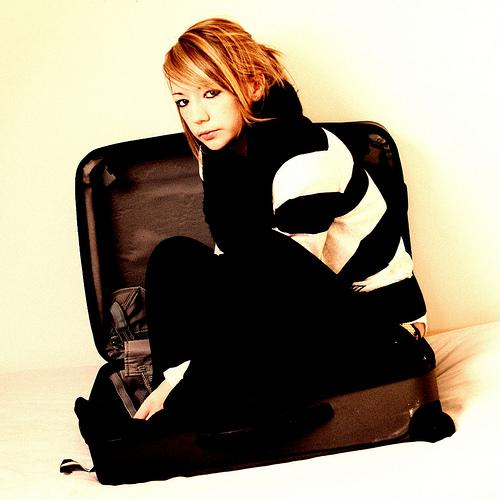Analyze the interaction between the woman and the objects in the image. The woman is actively engaging with the suitcase by sitting inside it, with her hand placed inside, and there's a tag on the suitcase and its handle is mentioned as well. Can you describe the appearance and clothing of the woman in the picture? The woman has red hair with blonde highlights, wearing a black and white striped sweater and black pants, along with a black scarf around her neck. Briefly evaluate the overall quality of this image based on the descriptions provided. The image seems to be of high quality, as there are many detailed descriptions, including various objects, their positions, and distinct attributes. Can you describe any accessories that the woman is wearing? The woman is wearing a small stud earring in her left ear. What features can you discern about the suitcase in the image? The suitcase is black, has a handle and a wheel, with a grey interior and buckle clasps, and it's placed on a bed. Identify the primary activity of the person in this image. A woman is sitting inside a suitcase. Estimate the sentiment and emotion conveyed by the image. The image conveys a positive, happy sentiment, as the woman seems to be having a good time enjoying the day. How many objects are mentioned in the image with their attributes? There are 45 objects mentioned, with varying attributes such as size, position, and appearance. Determine if the person is indoors or outdoors and provide reasoning. The person is indoors, as they are inside a room, and the suitcase is on a bed. Please count the number of objects related to the woman's clothing. There are 6 objects related to the woman's clothing: black pants, black and white striped sweater, black scarf, big black scarf, white striped shirt, and a black and white striped shirt. Is the suitcase made of transparent plastic and placed on a table? No, it's not mentioned in the image. Choose the correct description of the woman's hair: (a) red colored hair, (b) light brown hair with blonde highlights, or (c) black hair with blue highlights? (b) light brown hair with blonde highlights List three other captions describing the depicted scene in addition to the woman sitting in a suitcase. 1. A girl has light brown hair with blonde highlights. Describe the appearance of the suitcase where the woman is sitting. Black, with a handle, a wheel, and a buckle clasp Where is the suitcase located within the scene? On a bed Identify an object in the image that is part of the woman's clothing and describe its color. The sweater is black and white in color. What activity is the woman engaged in, and what object is she interacting with? Sitting in a suitcase What is the woman inside the suitcase doing? Sitting What accessory is worn around the woman's neck? Black scarf What type of makeup is visible around the woman's eyes? Black eyeliner Describe the atmosphere or time of day of the scene according to the image. Up in the daytime Describe the color and the style of the shirt the woman is wearing. White striped shirt with black and white stripes What color is the suitcase's interior? Grey Which facial features can you describe on the woman's face? Nose, lips, eyeliner around the eyes, eyebrow, and a small stud earring in the left ear. What color are the pants the woman is wearing? Black What kind of earring does the woman have in her left ear? Small stud earring Are there any wrinkles on the blanket under the suitcase in the image? Yes, wrinkles in the white blanket What emotion is the woman feeling according to the image captions? Having a good time and enjoying the day. 